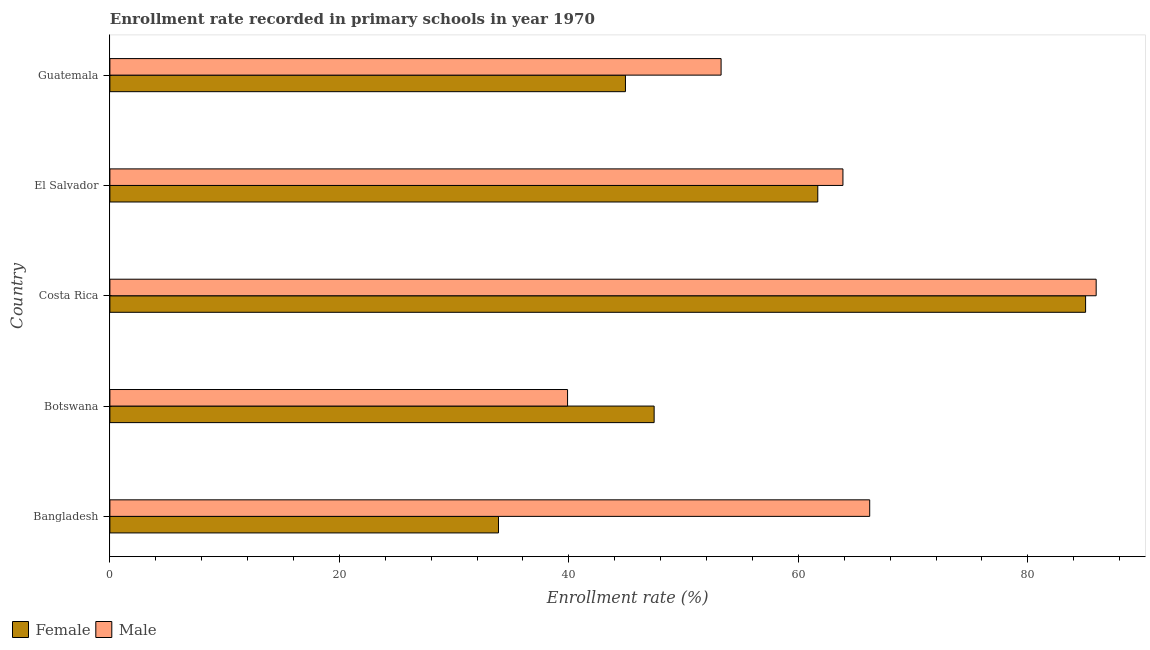Are the number of bars per tick equal to the number of legend labels?
Offer a very short reply. Yes. How many bars are there on the 3rd tick from the top?
Ensure brevity in your answer.  2. How many bars are there on the 2nd tick from the bottom?
Your response must be concise. 2. What is the label of the 4th group of bars from the top?
Provide a succinct answer. Botswana. In how many cases, is the number of bars for a given country not equal to the number of legend labels?
Make the answer very short. 0. What is the enrollment rate of male students in Bangladesh?
Your answer should be compact. 66.22. Across all countries, what is the maximum enrollment rate of male students?
Your response must be concise. 85.95. Across all countries, what is the minimum enrollment rate of male students?
Keep it short and to the point. 39.89. In which country was the enrollment rate of female students maximum?
Give a very brief answer. Costa Rica. In which country was the enrollment rate of male students minimum?
Make the answer very short. Botswana. What is the total enrollment rate of male students in the graph?
Give a very brief answer. 309.2. What is the difference between the enrollment rate of female students in Botswana and that in Costa Rica?
Your response must be concise. -37.6. What is the difference between the enrollment rate of female students in Bangladesh and the enrollment rate of male students in Guatemala?
Your answer should be compact. -19.4. What is the average enrollment rate of female students per country?
Provide a short and direct response. 54.59. What is the difference between the enrollment rate of female students and enrollment rate of male students in Costa Rica?
Offer a very short reply. -0.92. In how many countries, is the enrollment rate of male students greater than 48 %?
Ensure brevity in your answer.  4. What is the ratio of the enrollment rate of female students in El Salvador to that in Guatemala?
Give a very brief answer. 1.37. Is the difference between the enrollment rate of male students in Bangladesh and Botswana greater than the difference between the enrollment rate of female students in Bangladesh and Botswana?
Give a very brief answer. Yes. What is the difference between the highest and the second highest enrollment rate of male students?
Offer a terse response. 19.74. What is the difference between the highest and the lowest enrollment rate of female students?
Your answer should be compact. 51.17. How many bars are there?
Offer a terse response. 10. Are all the bars in the graph horizontal?
Provide a succinct answer. Yes. What is the difference between two consecutive major ticks on the X-axis?
Give a very brief answer. 20. Where does the legend appear in the graph?
Your response must be concise. Bottom left. What is the title of the graph?
Keep it short and to the point. Enrollment rate recorded in primary schools in year 1970. What is the label or title of the X-axis?
Offer a very short reply. Enrollment rate (%). What is the label or title of the Y-axis?
Give a very brief answer. Country. What is the Enrollment rate (%) in Female in Bangladesh?
Keep it short and to the point. 33.86. What is the Enrollment rate (%) of Male in Bangladesh?
Give a very brief answer. 66.22. What is the Enrollment rate (%) of Female in Botswana?
Offer a very short reply. 47.43. What is the Enrollment rate (%) in Male in Botswana?
Provide a short and direct response. 39.89. What is the Enrollment rate (%) of Female in Costa Rica?
Keep it short and to the point. 85.03. What is the Enrollment rate (%) of Male in Costa Rica?
Make the answer very short. 85.95. What is the Enrollment rate (%) of Female in El Salvador?
Your answer should be very brief. 61.69. What is the Enrollment rate (%) of Male in El Salvador?
Your answer should be very brief. 63.88. What is the Enrollment rate (%) of Female in Guatemala?
Offer a terse response. 44.93. What is the Enrollment rate (%) in Male in Guatemala?
Your response must be concise. 53.27. Across all countries, what is the maximum Enrollment rate (%) of Female?
Provide a short and direct response. 85.03. Across all countries, what is the maximum Enrollment rate (%) in Male?
Make the answer very short. 85.95. Across all countries, what is the minimum Enrollment rate (%) in Female?
Give a very brief answer. 33.86. Across all countries, what is the minimum Enrollment rate (%) in Male?
Your answer should be compact. 39.89. What is the total Enrollment rate (%) of Female in the graph?
Your response must be concise. 272.95. What is the total Enrollment rate (%) of Male in the graph?
Your response must be concise. 309.2. What is the difference between the Enrollment rate (%) of Female in Bangladesh and that in Botswana?
Your answer should be compact. -13.57. What is the difference between the Enrollment rate (%) in Male in Bangladesh and that in Botswana?
Keep it short and to the point. 26.33. What is the difference between the Enrollment rate (%) in Female in Bangladesh and that in Costa Rica?
Your answer should be very brief. -51.17. What is the difference between the Enrollment rate (%) in Male in Bangladesh and that in Costa Rica?
Keep it short and to the point. -19.74. What is the difference between the Enrollment rate (%) in Female in Bangladesh and that in El Salvador?
Your response must be concise. -27.83. What is the difference between the Enrollment rate (%) of Male in Bangladesh and that in El Salvador?
Offer a terse response. 2.33. What is the difference between the Enrollment rate (%) of Female in Bangladesh and that in Guatemala?
Provide a short and direct response. -11.06. What is the difference between the Enrollment rate (%) of Male in Bangladesh and that in Guatemala?
Keep it short and to the point. 12.95. What is the difference between the Enrollment rate (%) in Female in Botswana and that in Costa Rica?
Offer a very short reply. -37.6. What is the difference between the Enrollment rate (%) in Male in Botswana and that in Costa Rica?
Offer a terse response. -46.07. What is the difference between the Enrollment rate (%) in Female in Botswana and that in El Salvador?
Provide a short and direct response. -14.26. What is the difference between the Enrollment rate (%) in Male in Botswana and that in El Salvador?
Keep it short and to the point. -24. What is the difference between the Enrollment rate (%) of Female in Botswana and that in Guatemala?
Offer a very short reply. 2.5. What is the difference between the Enrollment rate (%) of Male in Botswana and that in Guatemala?
Provide a succinct answer. -13.38. What is the difference between the Enrollment rate (%) in Female in Costa Rica and that in El Salvador?
Keep it short and to the point. 23.34. What is the difference between the Enrollment rate (%) in Male in Costa Rica and that in El Salvador?
Your answer should be compact. 22.07. What is the difference between the Enrollment rate (%) in Female in Costa Rica and that in Guatemala?
Offer a very short reply. 40.1. What is the difference between the Enrollment rate (%) in Male in Costa Rica and that in Guatemala?
Your answer should be compact. 32.69. What is the difference between the Enrollment rate (%) in Female in El Salvador and that in Guatemala?
Provide a succinct answer. 16.76. What is the difference between the Enrollment rate (%) in Male in El Salvador and that in Guatemala?
Keep it short and to the point. 10.62. What is the difference between the Enrollment rate (%) of Female in Bangladesh and the Enrollment rate (%) of Male in Botswana?
Keep it short and to the point. -6.02. What is the difference between the Enrollment rate (%) in Female in Bangladesh and the Enrollment rate (%) in Male in Costa Rica?
Keep it short and to the point. -52.09. What is the difference between the Enrollment rate (%) in Female in Bangladesh and the Enrollment rate (%) in Male in El Salvador?
Provide a short and direct response. -30.02. What is the difference between the Enrollment rate (%) of Female in Bangladesh and the Enrollment rate (%) of Male in Guatemala?
Keep it short and to the point. -19.4. What is the difference between the Enrollment rate (%) of Female in Botswana and the Enrollment rate (%) of Male in Costa Rica?
Provide a succinct answer. -38.52. What is the difference between the Enrollment rate (%) of Female in Botswana and the Enrollment rate (%) of Male in El Salvador?
Your response must be concise. -16.45. What is the difference between the Enrollment rate (%) in Female in Botswana and the Enrollment rate (%) in Male in Guatemala?
Ensure brevity in your answer.  -5.84. What is the difference between the Enrollment rate (%) in Female in Costa Rica and the Enrollment rate (%) in Male in El Salvador?
Keep it short and to the point. 21.15. What is the difference between the Enrollment rate (%) in Female in Costa Rica and the Enrollment rate (%) in Male in Guatemala?
Your answer should be compact. 31.77. What is the difference between the Enrollment rate (%) of Female in El Salvador and the Enrollment rate (%) of Male in Guatemala?
Make the answer very short. 8.43. What is the average Enrollment rate (%) in Female per country?
Keep it short and to the point. 54.59. What is the average Enrollment rate (%) in Male per country?
Your response must be concise. 61.84. What is the difference between the Enrollment rate (%) of Female and Enrollment rate (%) of Male in Bangladesh?
Offer a very short reply. -32.35. What is the difference between the Enrollment rate (%) in Female and Enrollment rate (%) in Male in Botswana?
Make the answer very short. 7.54. What is the difference between the Enrollment rate (%) in Female and Enrollment rate (%) in Male in Costa Rica?
Offer a very short reply. -0.92. What is the difference between the Enrollment rate (%) in Female and Enrollment rate (%) in Male in El Salvador?
Ensure brevity in your answer.  -2.19. What is the difference between the Enrollment rate (%) in Female and Enrollment rate (%) in Male in Guatemala?
Provide a short and direct response. -8.34. What is the ratio of the Enrollment rate (%) of Female in Bangladesh to that in Botswana?
Give a very brief answer. 0.71. What is the ratio of the Enrollment rate (%) of Male in Bangladesh to that in Botswana?
Offer a very short reply. 1.66. What is the ratio of the Enrollment rate (%) of Female in Bangladesh to that in Costa Rica?
Your answer should be very brief. 0.4. What is the ratio of the Enrollment rate (%) in Male in Bangladesh to that in Costa Rica?
Your answer should be compact. 0.77. What is the ratio of the Enrollment rate (%) in Female in Bangladesh to that in El Salvador?
Your response must be concise. 0.55. What is the ratio of the Enrollment rate (%) in Male in Bangladesh to that in El Salvador?
Make the answer very short. 1.04. What is the ratio of the Enrollment rate (%) of Female in Bangladesh to that in Guatemala?
Your response must be concise. 0.75. What is the ratio of the Enrollment rate (%) of Male in Bangladesh to that in Guatemala?
Your answer should be very brief. 1.24. What is the ratio of the Enrollment rate (%) in Female in Botswana to that in Costa Rica?
Your answer should be very brief. 0.56. What is the ratio of the Enrollment rate (%) of Male in Botswana to that in Costa Rica?
Your answer should be very brief. 0.46. What is the ratio of the Enrollment rate (%) in Female in Botswana to that in El Salvador?
Your answer should be compact. 0.77. What is the ratio of the Enrollment rate (%) of Male in Botswana to that in El Salvador?
Your answer should be compact. 0.62. What is the ratio of the Enrollment rate (%) of Female in Botswana to that in Guatemala?
Your answer should be compact. 1.06. What is the ratio of the Enrollment rate (%) in Male in Botswana to that in Guatemala?
Give a very brief answer. 0.75. What is the ratio of the Enrollment rate (%) in Female in Costa Rica to that in El Salvador?
Your answer should be very brief. 1.38. What is the ratio of the Enrollment rate (%) in Male in Costa Rica to that in El Salvador?
Ensure brevity in your answer.  1.35. What is the ratio of the Enrollment rate (%) in Female in Costa Rica to that in Guatemala?
Offer a very short reply. 1.89. What is the ratio of the Enrollment rate (%) of Male in Costa Rica to that in Guatemala?
Provide a succinct answer. 1.61. What is the ratio of the Enrollment rate (%) in Female in El Salvador to that in Guatemala?
Give a very brief answer. 1.37. What is the ratio of the Enrollment rate (%) in Male in El Salvador to that in Guatemala?
Provide a succinct answer. 1.2. What is the difference between the highest and the second highest Enrollment rate (%) of Female?
Your answer should be very brief. 23.34. What is the difference between the highest and the second highest Enrollment rate (%) in Male?
Give a very brief answer. 19.74. What is the difference between the highest and the lowest Enrollment rate (%) in Female?
Offer a terse response. 51.17. What is the difference between the highest and the lowest Enrollment rate (%) in Male?
Offer a very short reply. 46.07. 